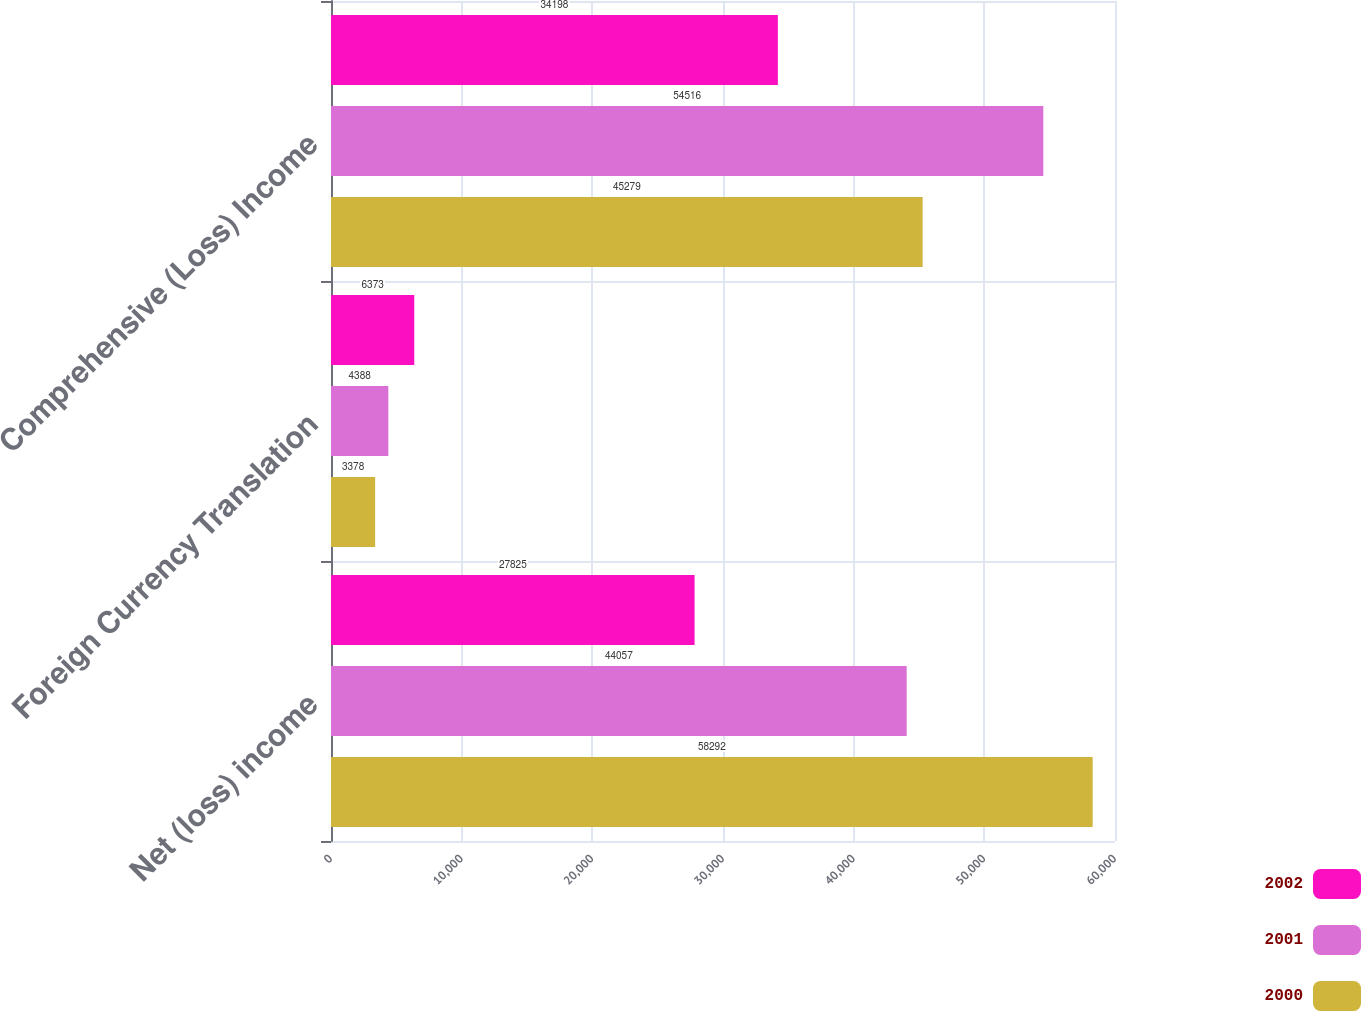<chart> <loc_0><loc_0><loc_500><loc_500><stacked_bar_chart><ecel><fcel>Net (loss) income<fcel>Foreign Currency Translation<fcel>Comprehensive (Loss) Income<nl><fcel>2002<fcel>27825<fcel>6373<fcel>34198<nl><fcel>2001<fcel>44057<fcel>4388<fcel>54516<nl><fcel>2000<fcel>58292<fcel>3378<fcel>45279<nl></chart> 